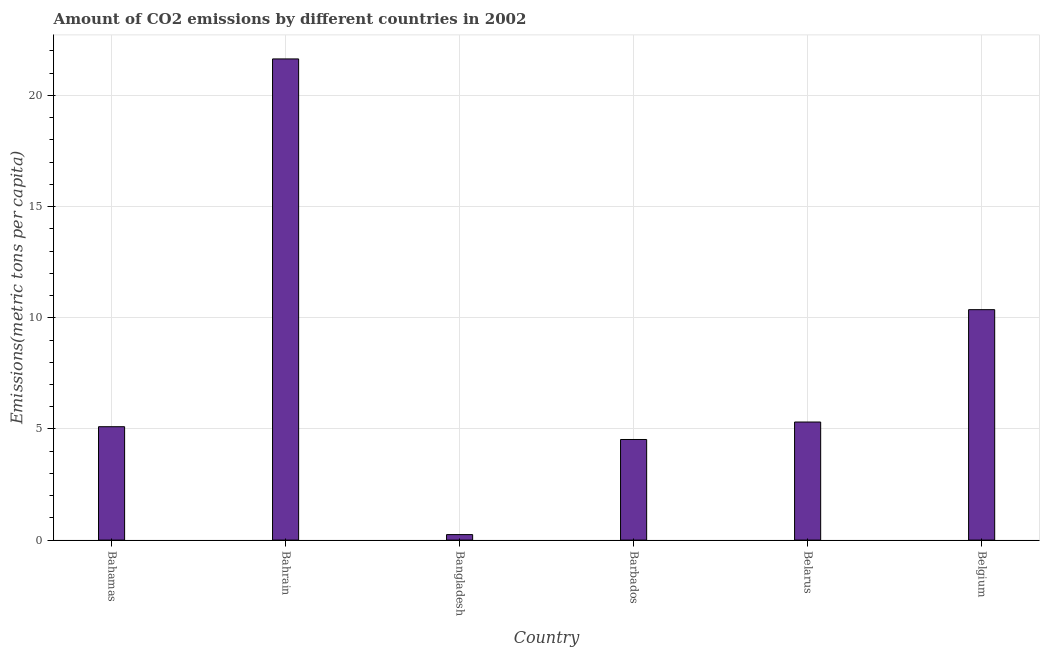Does the graph contain grids?
Offer a very short reply. Yes. What is the title of the graph?
Ensure brevity in your answer.  Amount of CO2 emissions by different countries in 2002. What is the label or title of the X-axis?
Make the answer very short. Country. What is the label or title of the Y-axis?
Offer a terse response. Emissions(metric tons per capita). What is the amount of co2 emissions in Belarus?
Your response must be concise. 5.31. Across all countries, what is the maximum amount of co2 emissions?
Your response must be concise. 21.64. Across all countries, what is the minimum amount of co2 emissions?
Keep it short and to the point. 0.25. In which country was the amount of co2 emissions maximum?
Offer a very short reply. Bahrain. What is the sum of the amount of co2 emissions?
Give a very brief answer. 47.19. What is the difference between the amount of co2 emissions in Bahamas and Barbados?
Offer a terse response. 0.57. What is the average amount of co2 emissions per country?
Provide a succinct answer. 7.87. What is the median amount of co2 emissions?
Ensure brevity in your answer.  5.21. In how many countries, is the amount of co2 emissions greater than 16 metric tons per capita?
Provide a short and direct response. 1. What is the ratio of the amount of co2 emissions in Bahrain to that in Barbados?
Offer a very short reply. 4.78. Is the difference between the amount of co2 emissions in Bahrain and Barbados greater than the difference between any two countries?
Your response must be concise. No. What is the difference between the highest and the second highest amount of co2 emissions?
Your answer should be very brief. 11.28. What is the difference between the highest and the lowest amount of co2 emissions?
Provide a short and direct response. 21.39. How many bars are there?
Offer a very short reply. 6. Are all the bars in the graph horizontal?
Offer a very short reply. No. How many countries are there in the graph?
Offer a very short reply. 6. Are the values on the major ticks of Y-axis written in scientific E-notation?
Give a very brief answer. No. What is the Emissions(metric tons per capita) of Bahamas?
Give a very brief answer. 5.1. What is the Emissions(metric tons per capita) of Bahrain?
Your answer should be compact. 21.64. What is the Emissions(metric tons per capita) in Bangladesh?
Your answer should be very brief. 0.25. What is the Emissions(metric tons per capita) of Barbados?
Your answer should be compact. 4.53. What is the Emissions(metric tons per capita) of Belarus?
Ensure brevity in your answer.  5.31. What is the Emissions(metric tons per capita) in Belgium?
Ensure brevity in your answer.  10.36. What is the difference between the Emissions(metric tons per capita) in Bahamas and Bahrain?
Make the answer very short. -16.54. What is the difference between the Emissions(metric tons per capita) in Bahamas and Bangladesh?
Make the answer very short. 4.85. What is the difference between the Emissions(metric tons per capita) in Bahamas and Barbados?
Offer a terse response. 0.58. What is the difference between the Emissions(metric tons per capita) in Bahamas and Belarus?
Provide a succinct answer. -0.21. What is the difference between the Emissions(metric tons per capita) in Bahamas and Belgium?
Your answer should be compact. -5.26. What is the difference between the Emissions(metric tons per capita) in Bahrain and Bangladesh?
Provide a short and direct response. 21.39. What is the difference between the Emissions(metric tons per capita) in Bahrain and Barbados?
Make the answer very short. 17.12. What is the difference between the Emissions(metric tons per capita) in Bahrain and Belarus?
Offer a terse response. 16.33. What is the difference between the Emissions(metric tons per capita) in Bahrain and Belgium?
Ensure brevity in your answer.  11.28. What is the difference between the Emissions(metric tons per capita) in Bangladesh and Barbados?
Provide a short and direct response. -4.28. What is the difference between the Emissions(metric tons per capita) in Bangladesh and Belarus?
Make the answer very short. -5.06. What is the difference between the Emissions(metric tons per capita) in Bangladesh and Belgium?
Provide a short and direct response. -10.12. What is the difference between the Emissions(metric tons per capita) in Barbados and Belarus?
Offer a terse response. -0.79. What is the difference between the Emissions(metric tons per capita) in Barbados and Belgium?
Provide a succinct answer. -5.84. What is the difference between the Emissions(metric tons per capita) in Belarus and Belgium?
Make the answer very short. -5.05. What is the ratio of the Emissions(metric tons per capita) in Bahamas to that in Bahrain?
Give a very brief answer. 0.24. What is the ratio of the Emissions(metric tons per capita) in Bahamas to that in Bangladesh?
Provide a succinct answer. 20.61. What is the ratio of the Emissions(metric tons per capita) in Bahamas to that in Barbados?
Give a very brief answer. 1.13. What is the ratio of the Emissions(metric tons per capita) in Bahamas to that in Belarus?
Give a very brief answer. 0.96. What is the ratio of the Emissions(metric tons per capita) in Bahamas to that in Belgium?
Your answer should be compact. 0.49. What is the ratio of the Emissions(metric tons per capita) in Bahrain to that in Bangladesh?
Ensure brevity in your answer.  87.47. What is the ratio of the Emissions(metric tons per capita) in Bahrain to that in Barbados?
Keep it short and to the point. 4.78. What is the ratio of the Emissions(metric tons per capita) in Bahrain to that in Belarus?
Offer a very short reply. 4.08. What is the ratio of the Emissions(metric tons per capita) in Bahrain to that in Belgium?
Provide a short and direct response. 2.09. What is the ratio of the Emissions(metric tons per capita) in Bangladesh to that in Barbados?
Your response must be concise. 0.06. What is the ratio of the Emissions(metric tons per capita) in Bangladesh to that in Belarus?
Give a very brief answer. 0.05. What is the ratio of the Emissions(metric tons per capita) in Bangladesh to that in Belgium?
Keep it short and to the point. 0.02. What is the ratio of the Emissions(metric tons per capita) in Barbados to that in Belarus?
Provide a short and direct response. 0.85. What is the ratio of the Emissions(metric tons per capita) in Barbados to that in Belgium?
Your response must be concise. 0.44. What is the ratio of the Emissions(metric tons per capita) in Belarus to that in Belgium?
Make the answer very short. 0.51. 